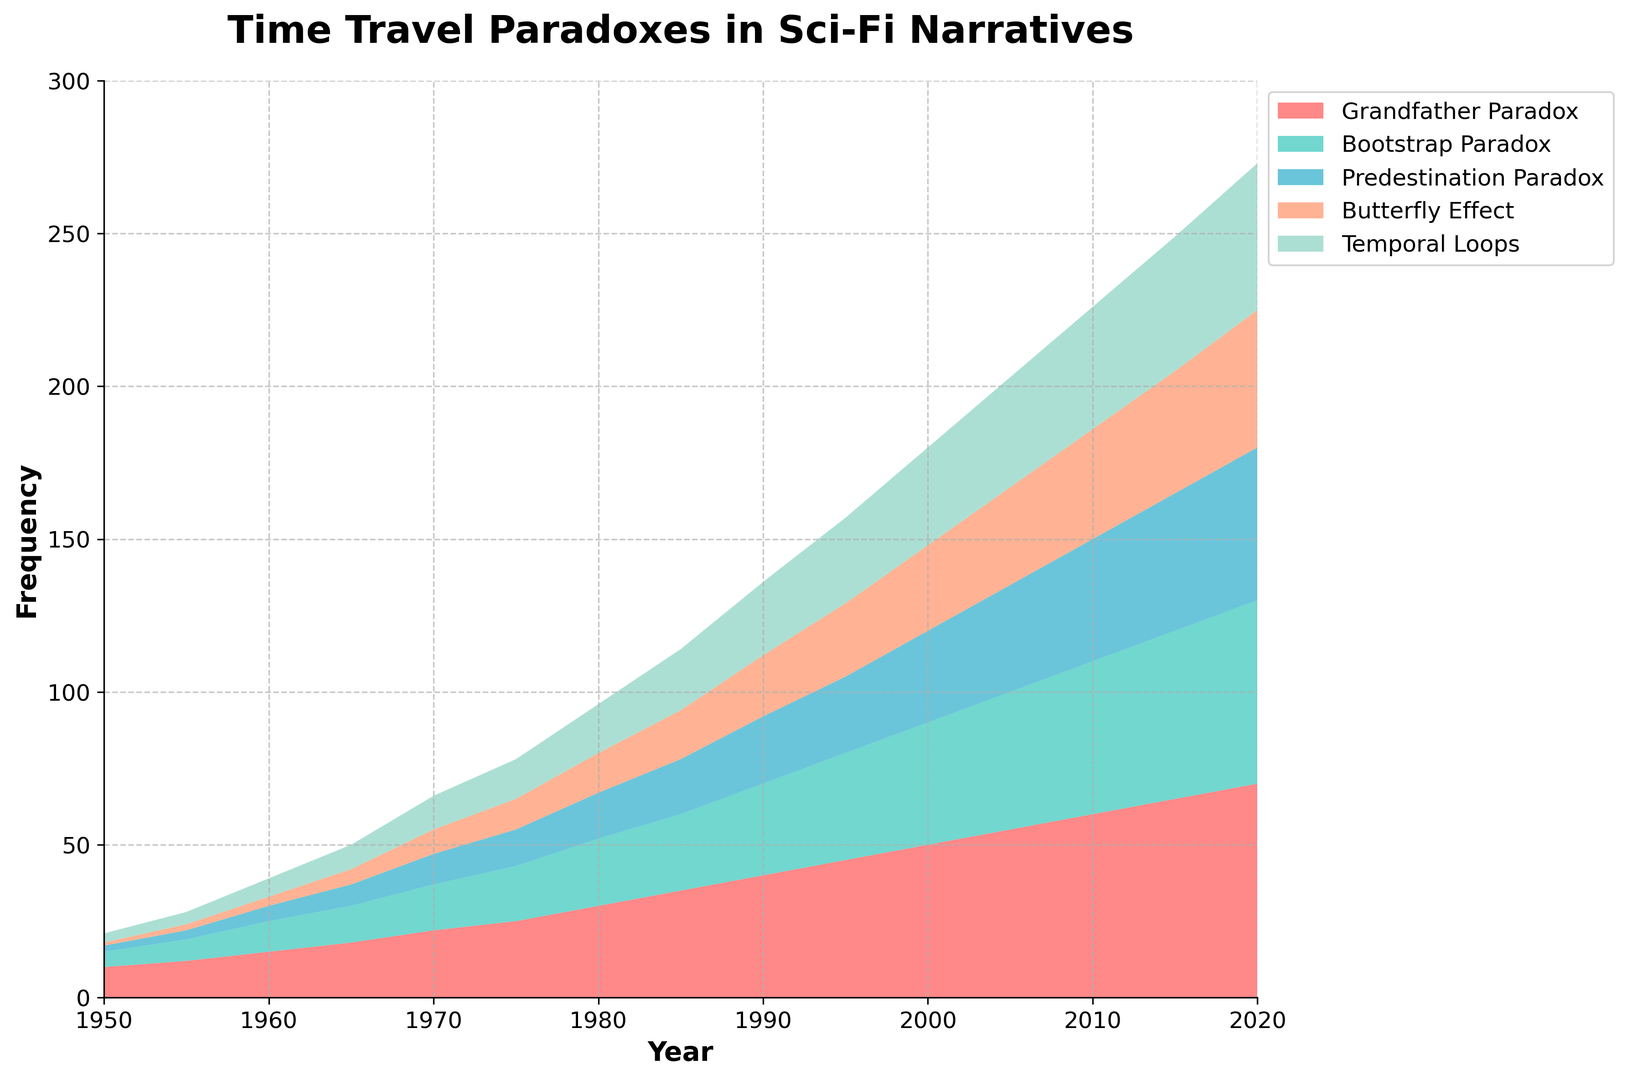What is the most frequently explored time travel paradox in 2020? By looking at the uppermost layer in the area chart for the year 2020, we can see that 'Grandfather Paradox' is the highest, indicating it is the most frequently explored paradox in 2020.
Answer: Grandfather Paradox In which decade did the frequency of 'Bootstraps Paradox' surpass 20? We need to find the point where the 'Bootstrap Paradox' layer crosses the value of 20 on the y-axis. In the year 1980, the frequency reaches 22, meaning it surpassed 20 in the 1980s.
Answer: 1980s How does the frequency of 'Butterfly Effect' in 1990 compare to 'Temporal Loops' in the same year? By comparing the heights of 'Butterfly Effect' and 'Temporal Loops' in the year 1990 on the chart, we see that 'Temporal Loops' (24) is depicted as higher than 'Butterfly Effect' (20).
Answer: Temporal Loops is higher What is the difference in frequency between 'Predestination Paradox' and 'Grandfather Paradox' in 2015? In 2015, 'Grandfather Paradox' is 65 and 'Predestination Paradox' is 45. The difference is calculated as 65 - 45.
Answer: 20 Which paradox showed the most significant increase in frequency between 1950 and 2000? By observing the chart from 1950 to 2000, we can see the increase for each paradox. 'Grandfather Paradox' jumps from 10 in 1950 to 50 in 2000, an increase of 40, which is the highest increase among all the paradoxes.
Answer: Grandfather Paradox How many paradoxes had their frequencies exceed 50 in the year 2010? In 2010, by looking at the portions of the chart that exceed the 50 mark on the y-axis, only 'Grandfather Paradox' exceeds this value.
Answer: 1 Is there any point where 'Temporal Loops' surpasses 'Bootstrap Paradox' in frequency? By examining the area chart layers, at no point does 'Temporal Loops' (the fifth layer) surpass the 'Bootstrap Paradox' (the second layer).
Answer: No What was the cumulative frequency of all paradoxes in 1970? Summing up the frequencies of all paradoxes for the year 1970: 22 (Grandfather Paradox) + 15 (Bootstrap Paradox) + 10 (Predestination Paradox) + 8 (Butterfly Effect) + 11 (Temporal Loops) = 66.
Answer: 66 Between 1980 and 1995, which paradox had the highest overall increase in frequency? Calculating the increase in frequency from 1980 to 1995 for each paradox: Grandfather Paradox (45-30 = 15), Bootstrap Paradox (35-22 = 13), Predestination Paradox (25-15 = 10), Butterfly Effect (24-13 = 11), Temporal Loops (28-16 = 12). 'Grandfather Paradox' has the highest increase of 15.
Answer: Grandfather Paradox What is the relation between the frequencies of 'Bootstraps Paradox' and 'Butterfly Effect' in 1965? By examining the layers in 1965, 'Bootstrap Paradox' (12) is higher in frequency compared to 'Butterfly Effect' (5).
Answer: Bootstrap Paradox is higher 